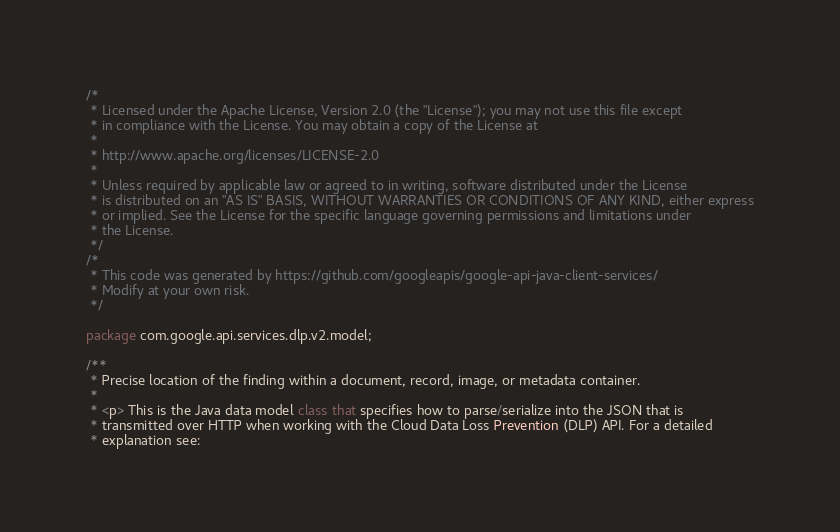<code> <loc_0><loc_0><loc_500><loc_500><_Java_>/*
 * Licensed under the Apache License, Version 2.0 (the "License"); you may not use this file except
 * in compliance with the License. You may obtain a copy of the License at
 *
 * http://www.apache.org/licenses/LICENSE-2.0
 *
 * Unless required by applicable law or agreed to in writing, software distributed under the License
 * is distributed on an "AS IS" BASIS, WITHOUT WARRANTIES OR CONDITIONS OF ANY KIND, either express
 * or implied. See the License for the specific language governing permissions and limitations under
 * the License.
 */
/*
 * This code was generated by https://github.com/googleapis/google-api-java-client-services/
 * Modify at your own risk.
 */

package com.google.api.services.dlp.v2.model;

/**
 * Precise location of the finding within a document, record, image, or metadata container.
 *
 * <p> This is the Java data model class that specifies how to parse/serialize into the JSON that is
 * transmitted over HTTP when working with the Cloud Data Loss Prevention (DLP) API. For a detailed
 * explanation see:</code> 